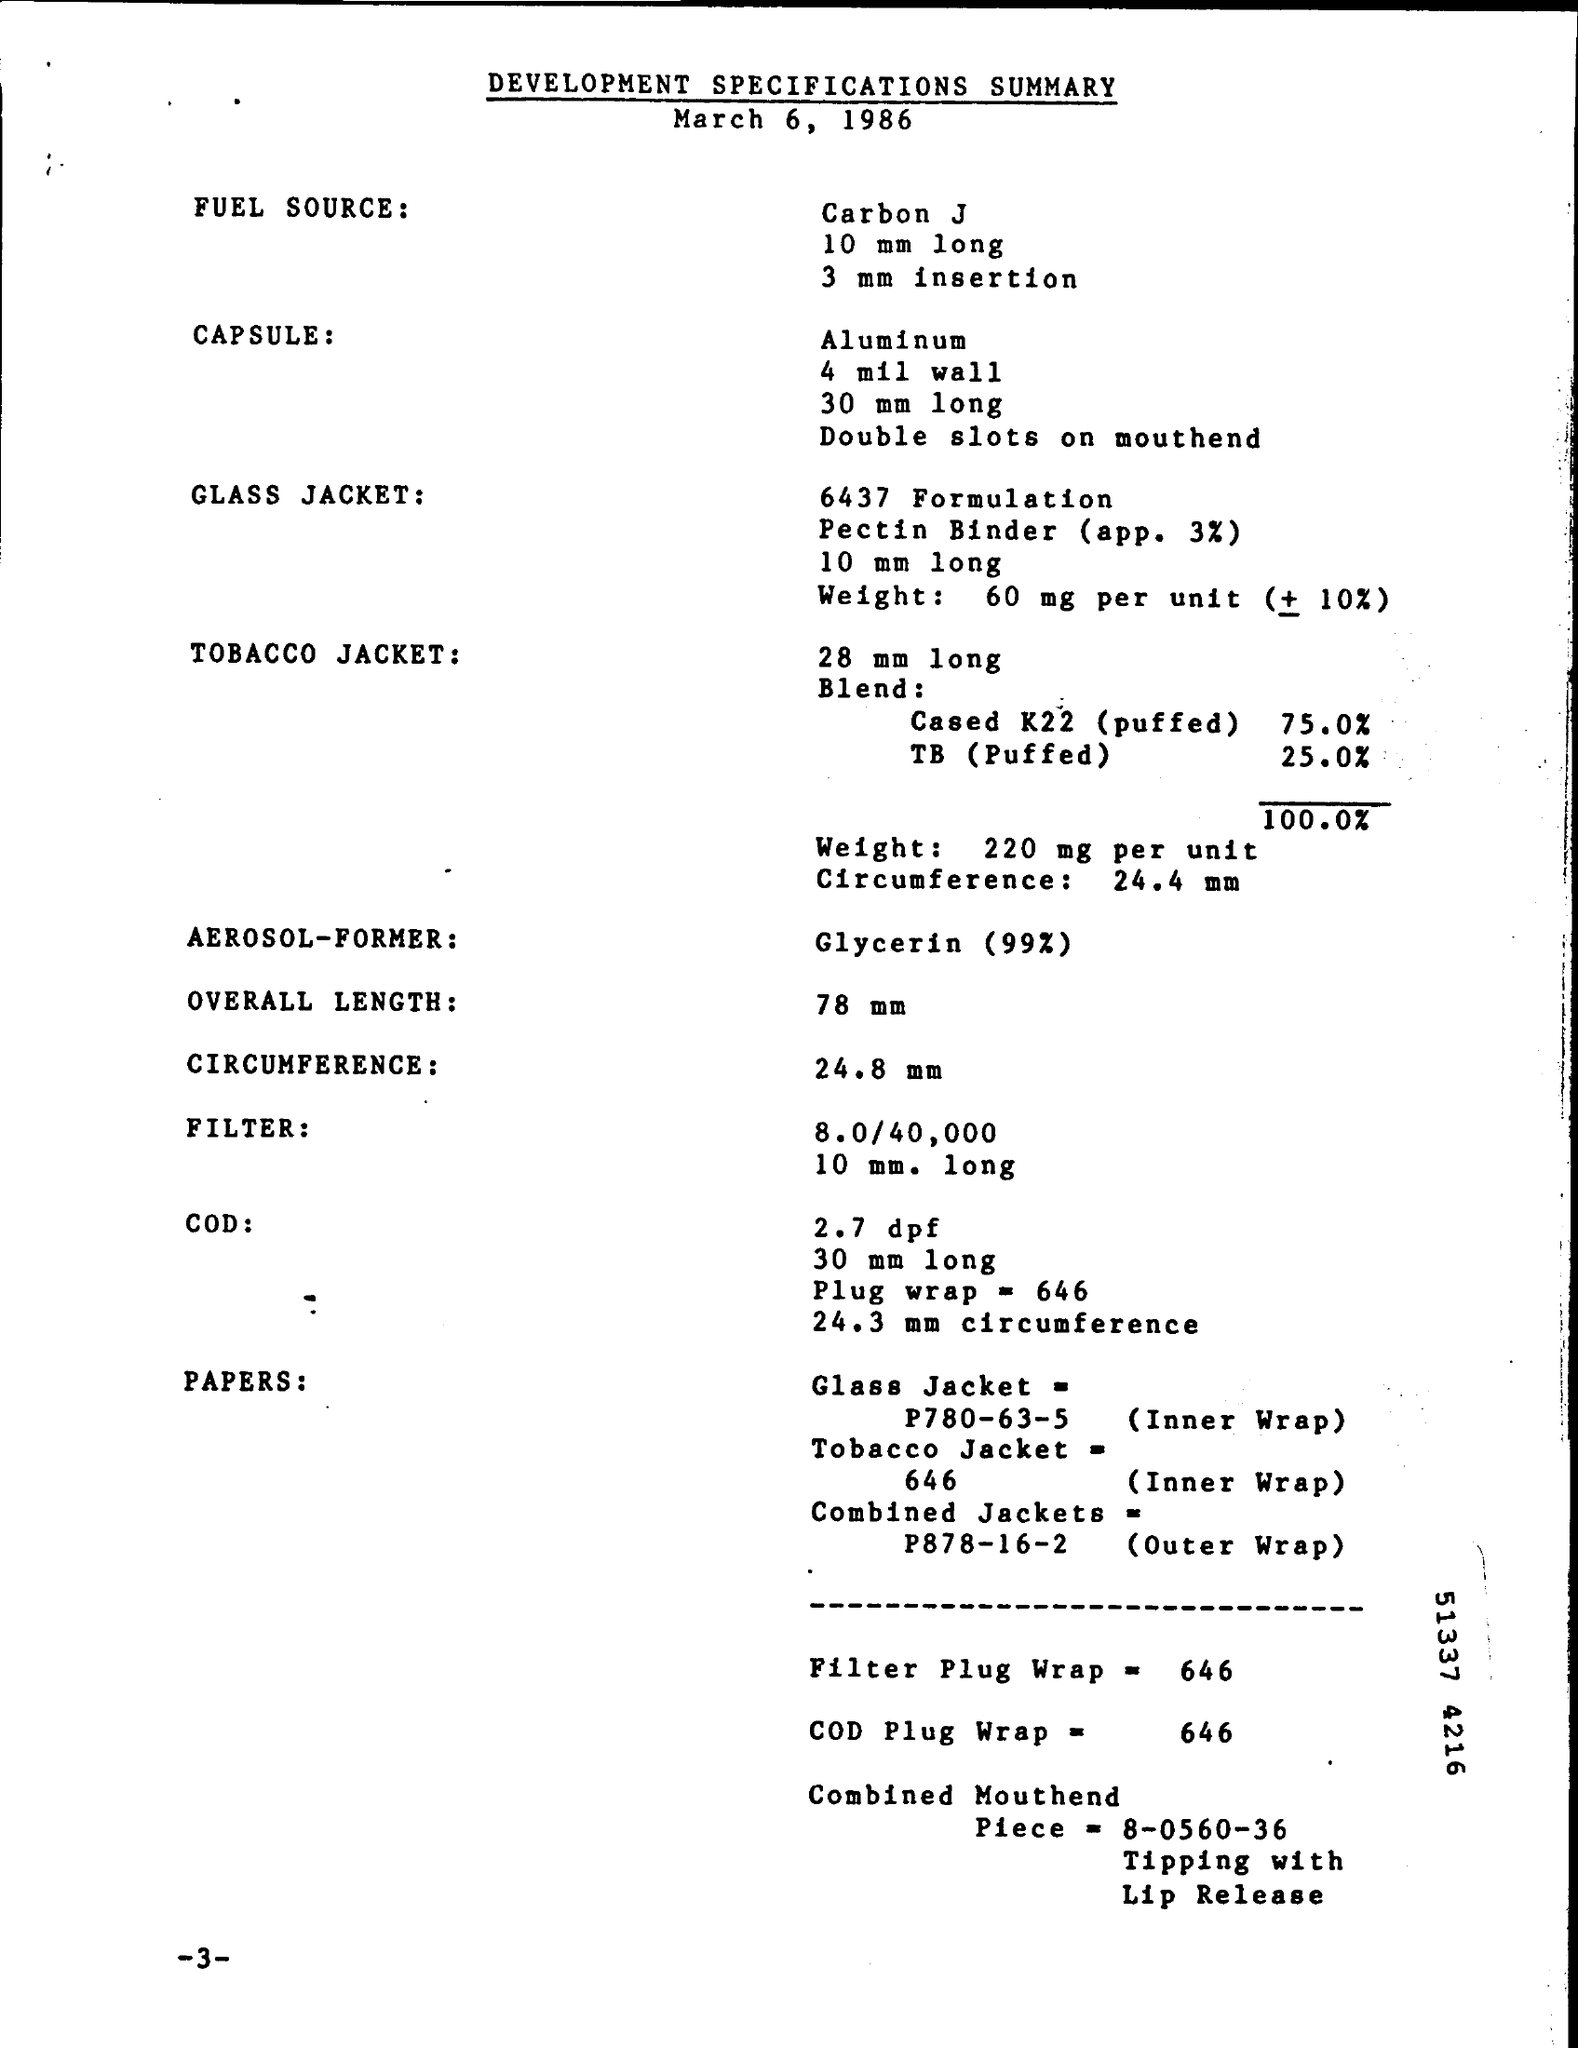Outline some significant characteristics in this image. The circumference of the tobacco jacket mentioned in the summary is 24.4 mm. The weight of tobacco jacket per unit is 220 milligrams. The length of the capsule mentioned in the summary is 30 mm. The length of the glass jacket mentioned in the summary is 10 mm long. Glycerin (99%) is the aerosol former mentioned in the summary. 